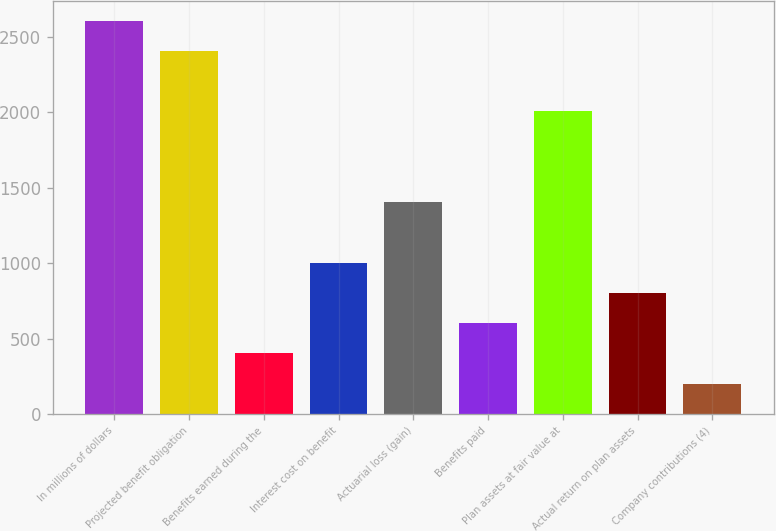Convert chart. <chart><loc_0><loc_0><loc_500><loc_500><bar_chart><fcel>In millions of dollars<fcel>Projected benefit obligation<fcel>Benefits earned during the<fcel>Interest cost on benefit<fcel>Actuarial loss (gain)<fcel>Benefits paid<fcel>Plan assets at fair value at<fcel>Actual return on plan assets<fcel>Company contributions (4)<nl><fcel>2608.8<fcel>2408.2<fcel>402.2<fcel>1004<fcel>1405.2<fcel>602.8<fcel>2007<fcel>803.4<fcel>201.6<nl></chart> 